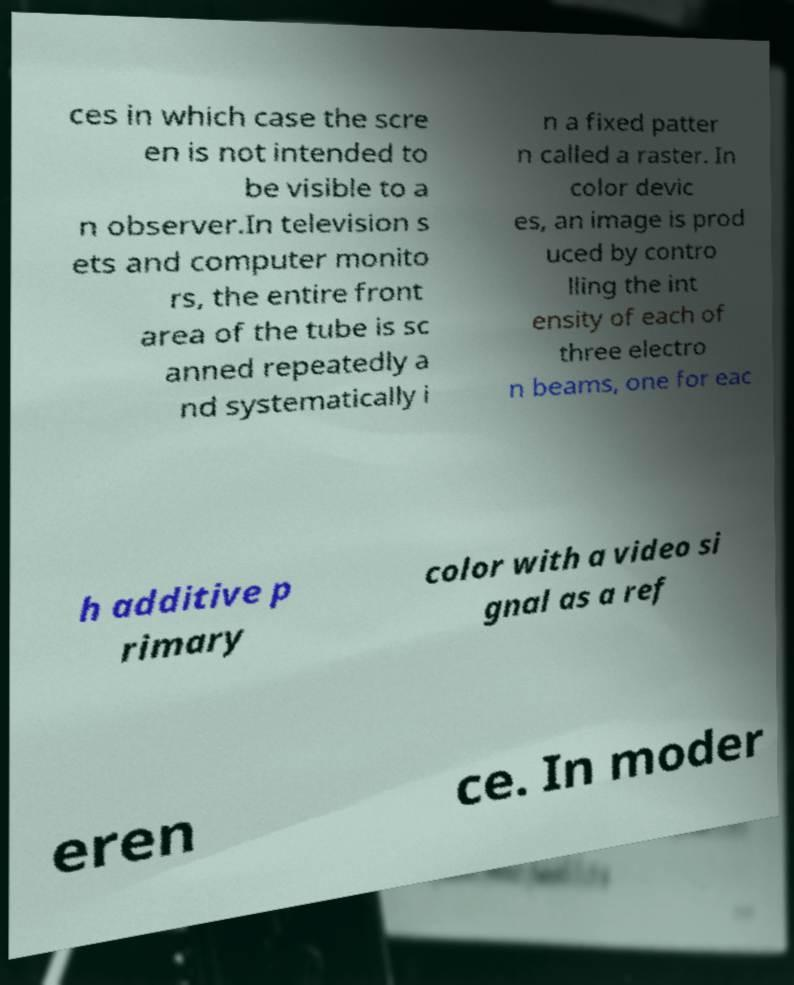Please identify and transcribe the text found in this image. ces in which case the scre en is not intended to be visible to a n observer.In television s ets and computer monito rs, the entire front area of the tube is sc anned repeatedly a nd systematically i n a fixed patter n called a raster. In color devic es, an image is prod uced by contro lling the int ensity of each of three electro n beams, one for eac h additive p rimary color with a video si gnal as a ref eren ce. In moder 